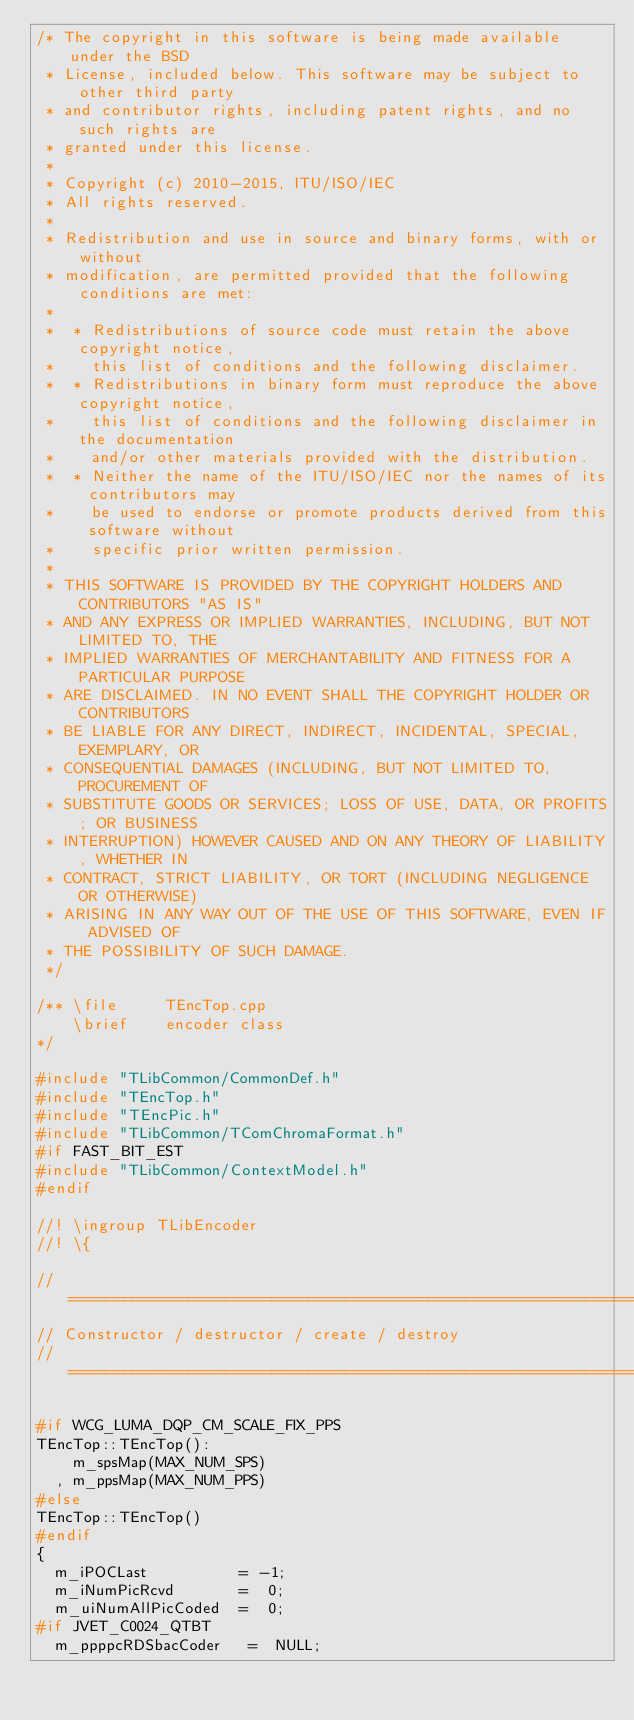<code> <loc_0><loc_0><loc_500><loc_500><_C++_>/* The copyright in this software is being made available under the BSD
 * License, included below. This software may be subject to other third party
 * and contributor rights, including patent rights, and no such rights are
 * granted under this license.
 *
 * Copyright (c) 2010-2015, ITU/ISO/IEC
 * All rights reserved.
 *
 * Redistribution and use in source and binary forms, with or without
 * modification, are permitted provided that the following conditions are met:
 *
 *  * Redistributions of source code must retain the above copyright notice,
 *    this list of conditions and the following disclaimer.
 *  * Redistributions in binary form must reproduce the above copyright notice,
 *    this list of conditions and the following disclaimer in the documentation
 *    and/or other materials provided with the distribution.
 *  * Neither the name of the ITU/ISO/IEC nor the names of its contributors may
 *    be used to endorse or promote products derived from this software without
 *    specific prior written permission.
 *
 * THIS SOFTWARE IS PROVIDED BY THE COPYRIGHT HOLDERS AND CONTRIBUTORS "AS IS"
 * AND ANY EXPRESS OR IMPLIED WARRANTIES, INCLUDING, BUT NOT LIMITED TO, THE
 * IMPLIED WARRANTIES OF MERCHANTABILITY AND FITNESS FOR A PARTICULAR PURPOSE
 * ARE DISCLAIMED. IN NO EVENT SHALL THE COPYRIGHT HOLDER OR CONTRIBUTORS
 * BE LIABLE FOR ANY DIRECT, INDIRECT, INCIDENTAL, SPECIAL, EXEMPLARY, OR
 * CONSEQUENTIAL DAMAGES (INCLUDING, BUT NOT LIMITED TO, PROCUREMENT OF
 * SUBSTITUTE GOODS OR SERVICES; LOSS OF USE, DATA, OR PROFITS; OR BUSINESS
 * INTERRUPTION) HOWEVER CAUSED AND ON ANY THEORY OF LIABILITY, WHETHER IN
 * CONTRACT, STRICT LIABILITY, OR TORT (INCLUDING NEGLIGENCE OR OTHERWISE)
 * ARISING IN ANY WAY OUT OF THE USE OF THIS SOFTWARE, EVEN IF ADVISED OF
 * THE POSSIBILITY OF SUCH DAMAGE.
 */

/** \file     TEncTop.cpp
    \brief    encoder class
*/

#include "TLibCommon/CommonDef.h"
#include "TEncTop.h"
#include "TEncPic.h"
#include "TLibCommon/TComChromaFormat.h"
#if FAST_BIT_EST
#include "TLibCommon/ContextModel.h"
#endif

//! \ingroup TLibEncoder
//! \{

// ====================================================================================================================
// Constructor / destructor / create / destroy
// ====================================================================================================================

#if WCG_LUMA_DQP_CM_SCALE_FIX_PPS
TEncTop::TEncTop():
    m_spsMap(MAX_NUM_SPS)
  , m_ppsMap(MAX_NUM_PPS)
#else
TEncTop::TEncTop()
#endif
{
  m_iPOCLast          = -1;
  m_iNumPicRcvd       =  0;
  m_uiNumAllPicCoded  =  0;
#if JVET_C0024_QTBT
  m_ppppcRDSbacCoder   =  NULL;</code> 